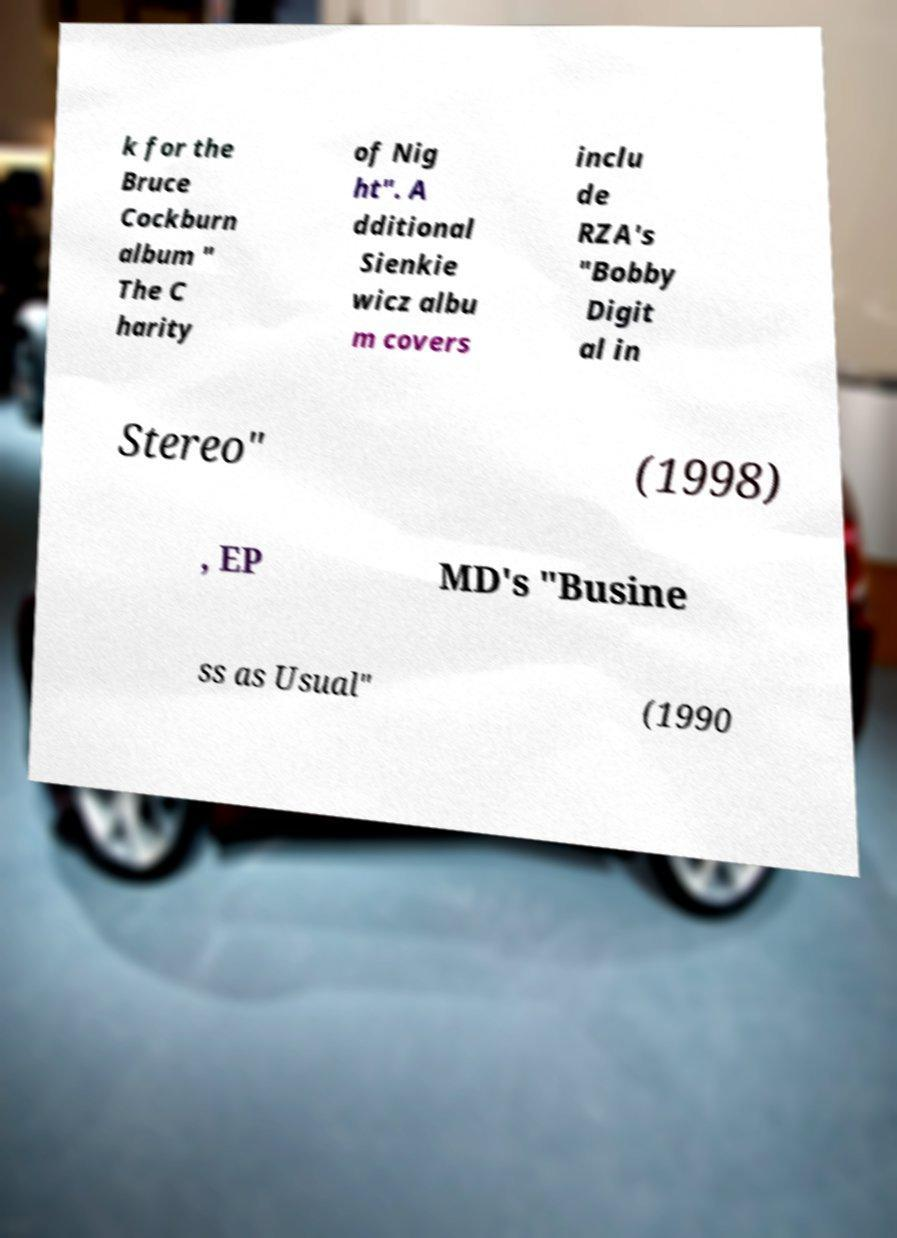I need the written content from this picture converted into text. Can you do that? k for the Bruce Cockburn album " The C harity of Nig ht". A dditional Sienkie wicz albu m covers inclu de RZA's "Bobby Digit al in Stereo" (1998) , EP MD's "Busine ss as Usual" (1990 